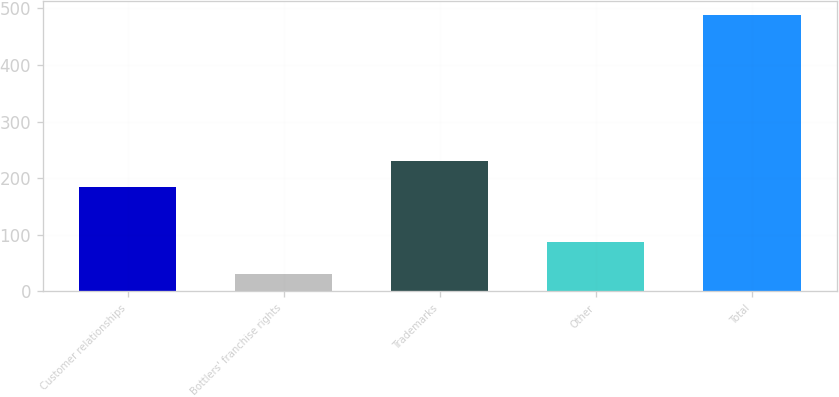Convert chart. <chart><loc_0><loc_0><loc_500><loc_500><bar_chart><fcel>Customer relationships<fcel>Bottlers' franchise rights<fcel>Trademarks<fcel>Other<fcel>Total<nl><fcel>185<fcel>30<fcel>230.9<fcel>88<fcel>489<nl></chart> 